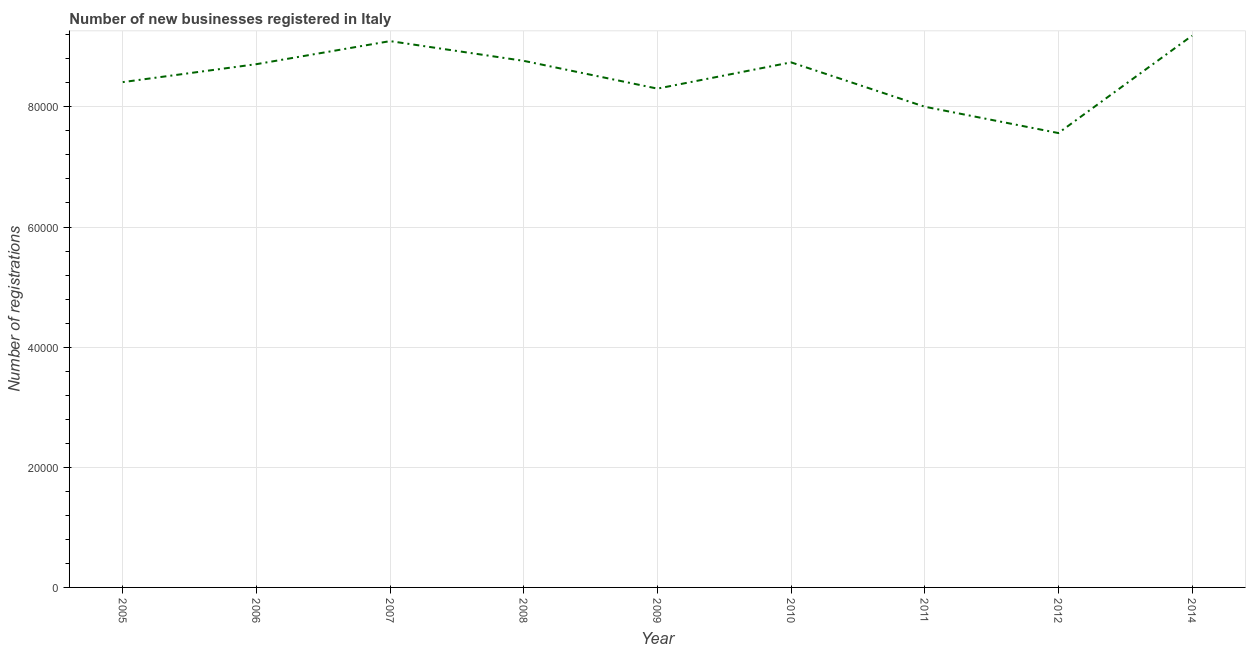What is the number of new business registrations in 2005?
Make the answer very short. 8.41e+04. Across all years, what is the maximum number of new business registrations?
Give a very brief answer. 9.19e+04. Across all years, what is the minimum number of new business registrations?
Keep it short and to the point. 7.56e+04. In which year was the number of new business registrations maximum?
Keep it short and to the point. 2014. In which year was the number of new business registrations minimum?
Make the answer very short. 2012. What is the sum of the number of new business registrations?
Make the answer very short. 7.68e+05. What is the difference between the number of new business registrations in 2006 and 2008?
Your response must be concise. -552. What is the average number of new business registrations per year?
Offer a very short reply. 8.53e+04. What is the median number of new business registrations?
Offer a very short reply. 8.71e+04. Do a majority of the years between 2005 and 2008 (inclusive) have number of new business registrations greater than 88000 ?
Keep it short and to the point. No. What is the ratio of the number of new business registrations in 2008 to that in 2009?
Offer a terse response. 1.06. Is the number of new business registrations in 2005 less than that in 2007?
Your response must be concise. Yes. Is the difference between the number of new business registrations in 2009 and 2012 greater than the difference between any two years?
Your answer should be very brief. No. What is the difference between the highest and the second highest number of new business registrations?
Your response must be concise. 903. Is the sum of the number of new business registrations in 2005 and 2009 greater than the maximum number of new business registrations across all years?
Your answer should be very brief. Yes. What is the difference between the highest and the lowest number of new business registrations?
Give a very brief answer. 1.62e+04. Does the number of new business registrations monotonically increase over the years?
Keep it short and to the point. No. How many lines are there?
Provide a succinct answer. 1. How many years are there in the graph?
Your response must be concise. 9. What is the title of the graph?
Offer a very short reply. Number of new businesses registered in Italy. What is the label or title of the X-axis?
Your answer should be compact. Year. What is the label or title of the Y-axis?
Make the answer very short. Number of registrations. What is the Number of registrations in 2005?
Make the answer very short. 8.41e+04. What is the Number of registrations in 2006?
Give a very brief answer. 8.71e+04. What is the Number of registrations of 2007?
Offer a terse response. 9.10e+04. What is the Number of registrations of 2008?
Your answer should be very brief. 8.77e+04. What is the Number of registrations in 2009?
Keep it short and to the point. 8.30e+04. What is the Number of registrations in 2010?
Your answer should be very brief. 8.74e+04. What is the Number of registrations in 2011?
Make the answer very short. 8.00e+04. What is the Number of registrations in 2012?
Your response must be concise. 7.56e+04. What is the Number of registrations in 2014?
Your answer should be compact. 9.19e+04. What is the difference between the Number of registrations in 2005 and 2006?
Make the answer very short. -2988. What is the difference between the Number of registrations in 2005 and 2007?
Your answer should be very brief. -6825. What is the difference between the Number of registrations in 2005 and 2008?
Your answer should be compact. -3540. What is the difference between the Number of registrations in 2005 and 2009?
Provide a succinct answer. 1083. What is the difference between the Number of registrations in 2005 and 2010?
Your answer should be very brief. -3290. What is the difference between the Number of registrations in 2005 and 2011?
Offer a very short reply. 4097. What is the difference between the Number of registrations in 2005 and 2012?
Provide a short and direct response. 8480. What is the difference between the Number of registrations in 2005 and 2014?
Make the answer very short. -7728. What is the difference between the Number of registrations in 2006 and 2007?
Ensure brevity in your answer.  -3837. What is the difference between the Number of registrations in 2006 and 2008?
Offer a very short reply. -552. What is the difference between the Number of registrations in 2006 and 2009?
Your answer should be compact. 4071. What is the difference between the Number of registrations in 2006 and 2010?
Give a very brief answer. -302. What is the difference between the Number of registrations in 2006 and 2011?
Provide a short and direct response. 7085. What is the difference between the Number of registrations in 2006 and 2012?
Your answer should be very brief. 1.15e+04. What is the difference between the Number of registrations in 2006 and 2014?
Keep it short and to the point. -4740. What is the difference between the Number of registrations in 2007 and 2008?
Your answer should be very brief. 3285. What is the difference between the Number of registrations in 2007 and 2009?
Your answer should be very brief. 7908. What is the difference between the Number of registrations in 2007 and 2010?
Ensure brevity in your answer.  3535. What is the difference between the Number of registrations in 2007 and 2011?
Your answer should be compact. 1.09e+04. What is the difference between the Number of registrations in 2007 and 2012?
Give a very brief answer. 1.53e+04. What is the difference between the Number of registrations in 2007 and 2014?
Your answer should be compact. -903. What is the difference between the Number of registrations in 2008 and 2009?
Give a very brief answer. 4623. What is the difference between the Number of registrations in 2008 and 2010?
Give a very brief answer. 250. What is the difference between the Number of registrations in 2008 and 2011?
Make the answer very short. 7637. What is the difference between the Number of registrations in 2008 and 2012?
Provide a short and direct response. 1.20e+04. What is the difference between the Number of registrations in 2008 and 2014?
Keep it short and to the point. -4188. What is the difference between the Number of registrations in 2009 and 2010?
Ensure brevity in your answer.  -4373. What is the difference between the Number of registrations in 2009 and 2011?
Provide a short and direct response. 3014. What is the difference between the Number of registrations in 2009 and 2012?
Provide a short and direct response. 7397. What is the difference between the Number of registrations in 2009 and 2014?
Provide a short and direct response. -8811. What is the difference between the Number of registrations in 2010 and 2011?
Your response must be concise. 7387. What is the difference between the Number of registrations in 2010 and 2012?
Your response must be concise. 1.18e+04. What is the difference between the Number of registrations in 2010 and 2014?
Offer a terse response. -4438. What is the difference between the Number of registrations in 2011 and 2012?
Provide a short and direct response. 4383. What is the difference between the Number of registrations in 2011 and 2014?
Give a very brief answer. -1.18e+04. What is the difference between the Number of registrations in 2012 and 2014?
Your answer should be very brief. -1.62e+04. What is the ratio of the Number of registrations in 2005 to that in 2006?
Your response must be concise. 0.97. What is the ratio of the Number of registrations in 2005 to that in 2007?
Your answer should be very brief. 0.93. What is the ratio of the Number of registrations in 2005 to that in 2008?
Ensure brevity in your answer.  0.96. What is the ratio of the Number of registrations in 2005 to that in 2009?
Ensure brevity in your answer.  1.01. What is the ratio of the Number of registrations in 2005 to that in 2010?
Ensure brevity in your answer.  0.96. What is the ratio of the Number of registrations in 2005 to that in 2011?
Your answer should be very brief. 1.05. What is the ratio of the Number of registrations in 2005 to that in 2012?
Provide a short and direct response. 1.11. What is the ratio of the Number of registrations in 2005 to that in 2014?
Provide a succinct answer. 0.92. What is the ratio of the Number of registrations in 2006 to that in 2007?
Your answer should be very brief. 0.96. What is the ratio of the Number of registrations in 2006 to that in 2009?
Make the answer very short. 1.05. What is the ratio of the Number of registrations in 2006 to that in 2010?
Keep it short and to the point. 1. What is the ratio of the Number of registrations in 2006 to that in 2011?
Your answer should be compact. 1.09. What is the ratio of the Number of registrations in 2006 to that in 2012?
Make the answer very short. 1.15. What is the ratio of the Number of registrations in 2006 to that in 2014?
Your response must be concise. 0.95. What is the ratio of the Number of registrations in 2007 to that in 2008?
Make the answer very short. 1.04. What is the ratio of the Number of registrations in 2007 to that in 2009?
Your response must be concise. 1.09. What is the ratio of the Number of registrations in 2007 to that in 2010?
Your response must be concise. 1.04. What is the ratio of the Number of registrations in 2007 to that in 2011?
Make the answer very short. 1.14. What is the ratio of the Number of registrations in 2007 to that in 2012?
Provide a succinct answer. 1.2. What is the ratio of the Number of registrations in 2008 to that in 2009?
Your answer should be very brief. 1.06. What is the ratio of the Number of registrations in 2008 to that in 2011?
Provide a short and direct response. 1.09. What is the ratio of the Number of registrations in 2008 to that in 2012?
Ensure brevity in your answer.  1.16. What is the ratio of the Number of registrations in 2008 to that in 2014?
Offer a very short reply. 0.95. What is the ratio of the Number of registrations in 2009 to that in 2010?
Ensure brevity in your answer.  0.95. What is the ratio of the Number of registrations in 2009 to that in 2011?
Your answer should be very brief. 1.04. What is the ratio of the Number of registrations in 2009 to that in 2012?
Your answer should be compact. 1.1. What is the ratio of the Number of registrations in 2009 to that in 2014?
Ensure brevity in your answer.  0.9. What is the ratio of the Number of registrations in 2010 to that in 2011?
Offer a terse response. 1.09. What is the ratio of the Number of registrations in 2010 to that in 2012?
Offer a very short reply. 1.16. What is the ratio of the Number of registrations in 2011 to that in 2012?
Offer a terse response. 1.06. What is the ratio of the Number of registrations in 2011 to that in 2014?
Offer a very short reply. 0.87. What is the ratio of the Number of registrations in 2012 to that in 2014?
Ensure brevity in your answer.  0.82. 